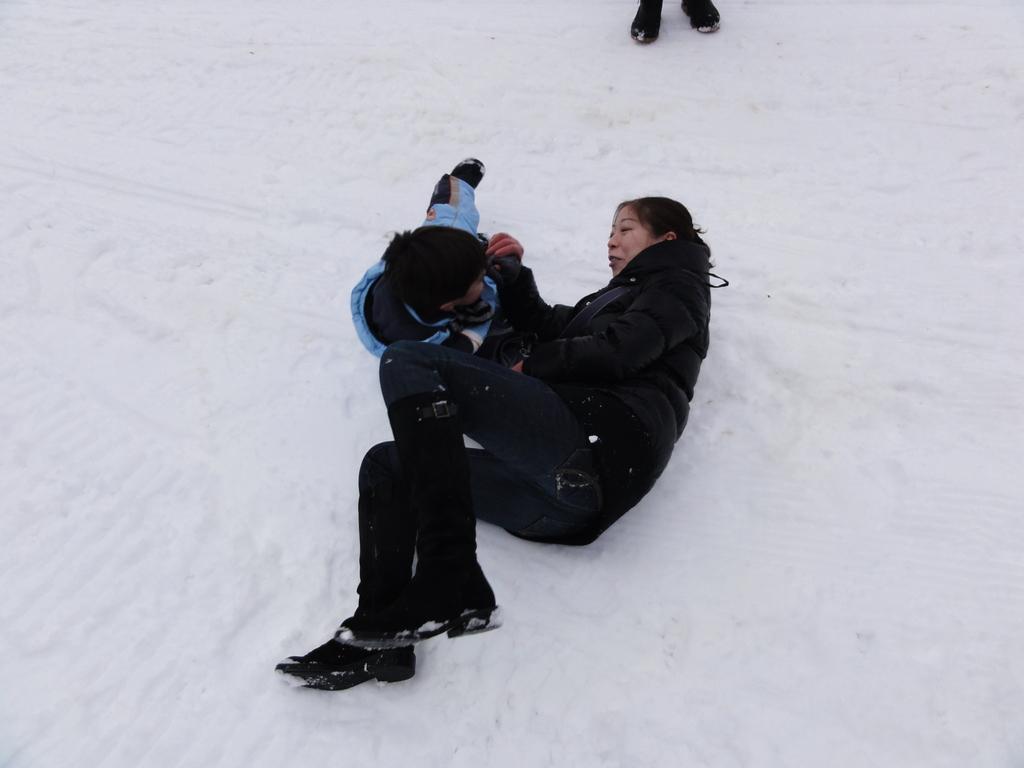In one or two sentences, can you explain what this image depicts? The woman and her kid are playing in snow. The woman holding her kid. Women wore black jacket, jeans and black boots. 